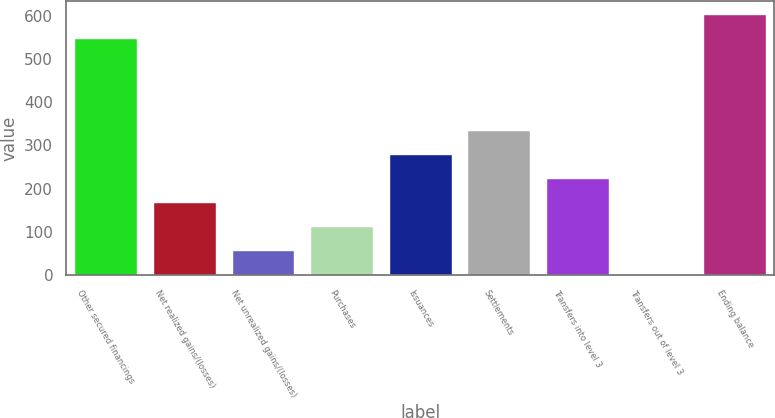Convert chart. <chart><loc_0><loc_0><loc_500><loc_500><bar_chart><fcel>Other secured financings<fcel>Net realized gains/(losses)<fcel>Net unrealized gains/(losses)<fcel>Purchases<fcel>Issuances<fcel>Settlements<fcel>Transfers into level 3<fcel>Transfers out of level 3<fcel>Ending balance<nl><fcel>549<fcel>168.5<fcel>57.5<fcel>113<fcel>279.5<fcel>335<fcel>224<fcel>2<fcel>604.5<nl></chart> 